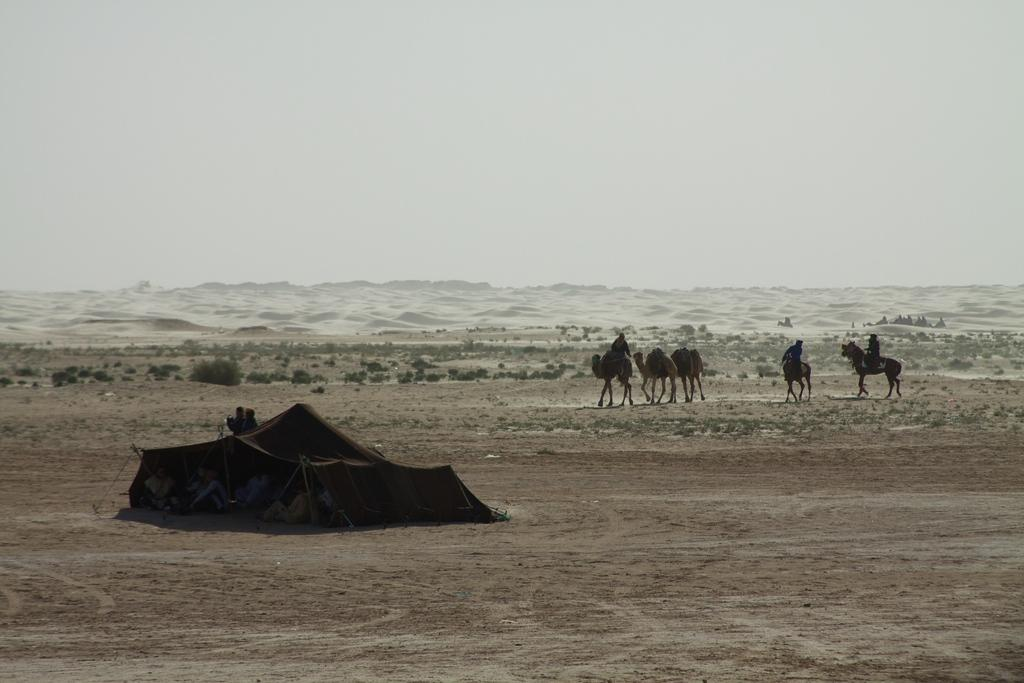What structure is on the ground in the image? There is a tent on the ground in the image. What animals are present in the image? There are camels in the image. What type of vegetation can be seen in the image? There are plants in the image. What is the texture of the ground in the image? The ground appears to be sand. What is visible in the background of the image? The sky is visible in the background of the image. Where is the nearest store to buy thrilling items in the image? There is no store present in the image, and the context of the image does not suggest the presence of a store nearby. 